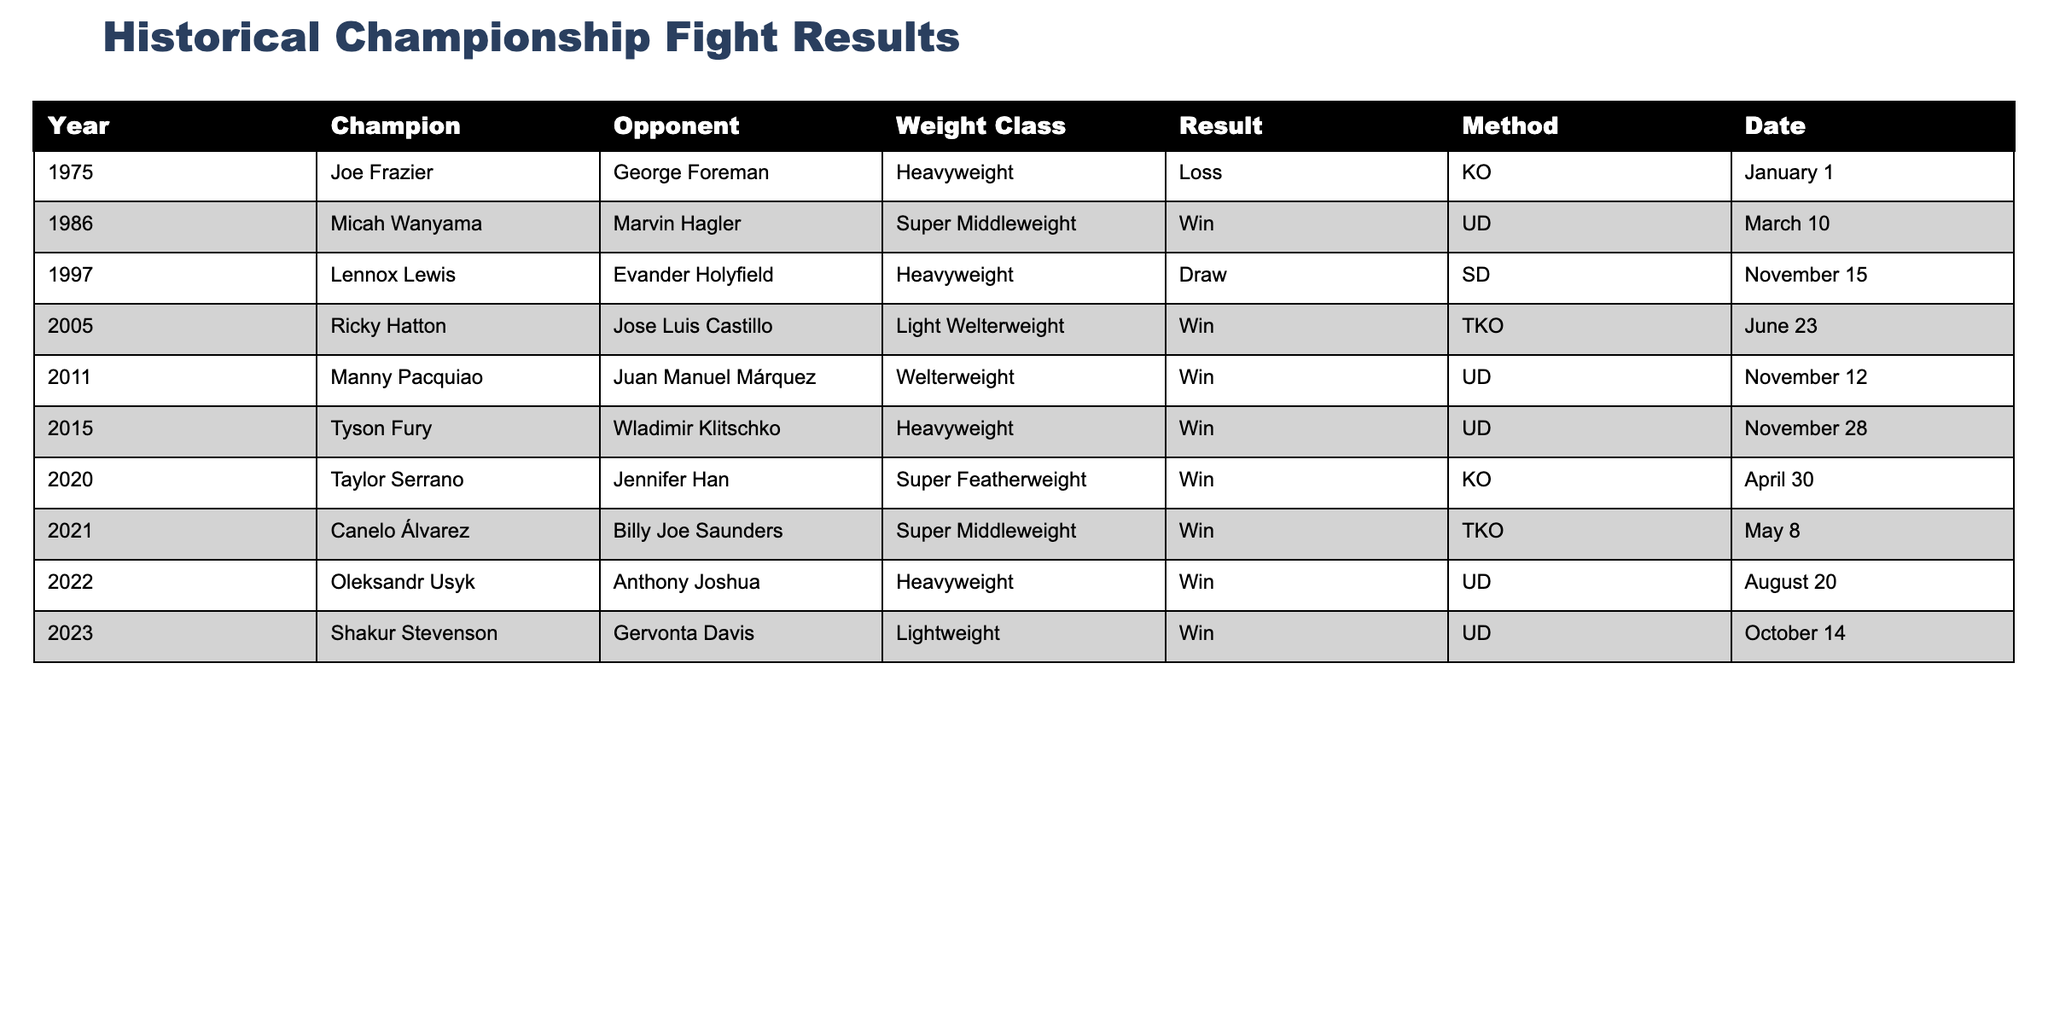What year did Joe Frazier fight George Foreman? Joe Frazier fought George Foreman in the year 1975, as indicated in the table under the Year column for that fight.
Answer: 1975 Who won the fight between Manny Pacquiao and Juan Manuel Márquez? According to the table, Manny Pacquiao won the fight against Juan Manuel Márquez by unanimous decision (UD).
Answer: Manny Pacquiao How many fights in the table resulted in a loss for the champion? There is one fight in the table that resulted in a loss for the champion, which is Joe Frazier's loss to George Foreman by knockout (KO).
Answer: 1 What was the method of victory for Tyson Fury in his fight against Wladimir Klitschko? The table shows that Tyson Fury won his fight against Wladimir Klitschko by unanimous decision (UD).
Answer: Unanimous decision How many years are represented in the table? The table spans from 1975 to 2023, which includes 49 years. The years represented are 1975, 1986, 1997, 2005, 2011, 2015, 2020, 2021, 2022, and 2023, totaling 10 unique years.
Answer: 10 Was there any fight that ended in a draw? Yes, the fight between Lennox Lewis and Evander Holyfield ended in a draw, as stated in the Result column of the table.
Answer: Yes In which weight class did Ricky Hatton fight Jose Luis Castillo? The table indicates that Ricky Hatton fought Jose Luis Castillo in the Light Welterweight class.
Answer: Light Welterweight Which fighter had the earliest fight listed in the table? The earliest fight listed in the table is Joe Frazier vs. George Foreman in 1975, which is the first entry of the table.
Answer: Joe Frazier How many champions won their fights by knockout (KO)? The table lists two champions who won their fights by knockout (KO): Joe Frazier and Taylor Serrano.
Answer: 2 What is the total number of fights represented between champions in the Heavyweight class? The table shows a total of four Heavyweight fights involving champions: Joe Frazier vs. George Foreman, Lennox Lewis vs. Evander Holyfield, Tyson Fury vs. Wladimir Klitschko, and Oleksandr Usyk vs. Anthony Joshua.
Answer: 4 